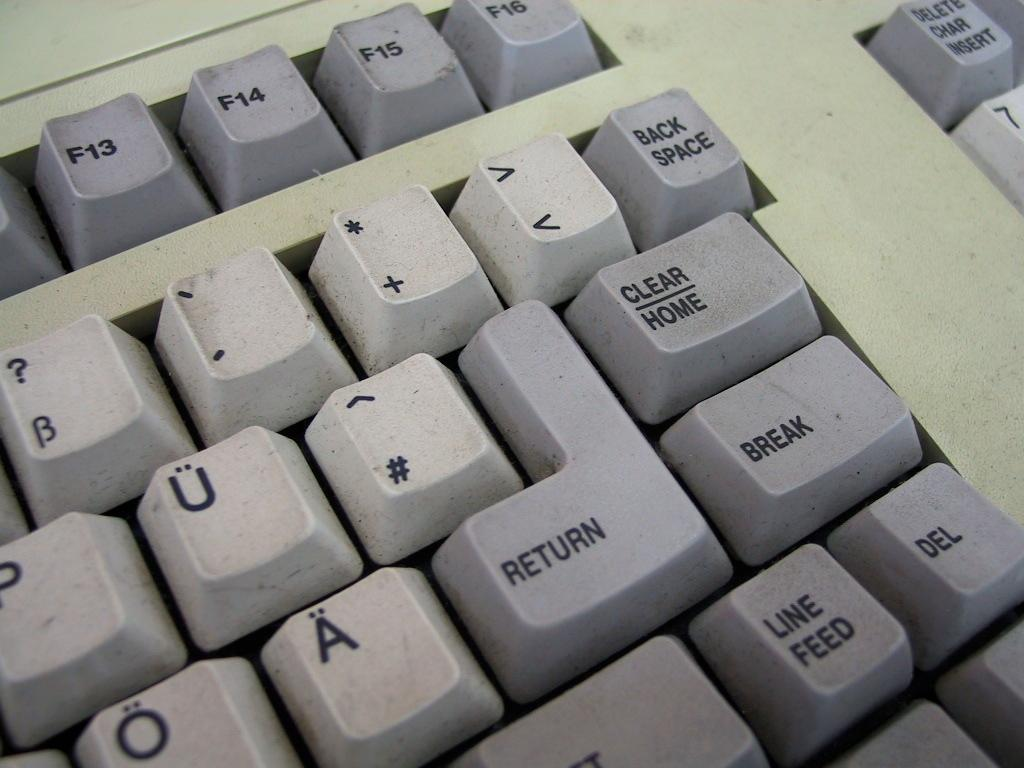<image>
Present a compact description of the photo's key features. Black and grey keyboard that says "Return" near the middle. 